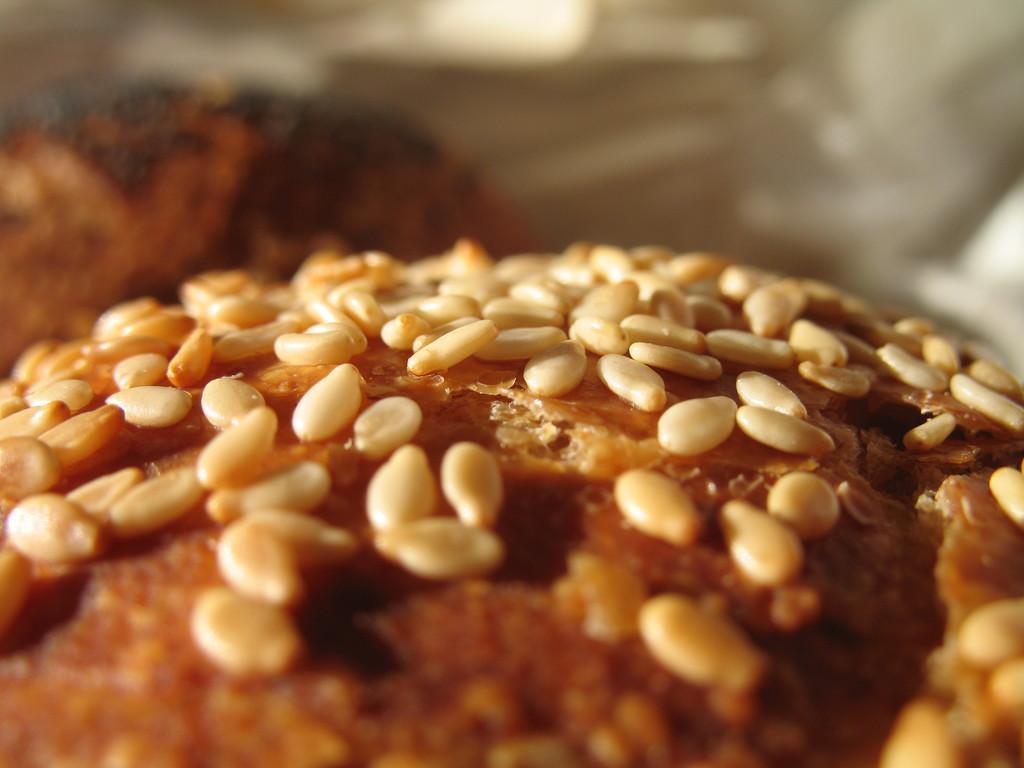Describe this image in one or two sentences. In this image there is a cup cake in the middle. On the cake there are so many seeds. 